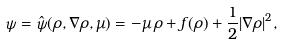<formula> <loc_0><loc_0><loc_500><loc_500>\psi = \hat { \psi } ( \rho , \nabla \rho , \mu ) = - \mu \, \rho + f ( \rho ) + \frac { 1 } { 2 } | \nabla \rho | ^ { 2 } ,</formula> 